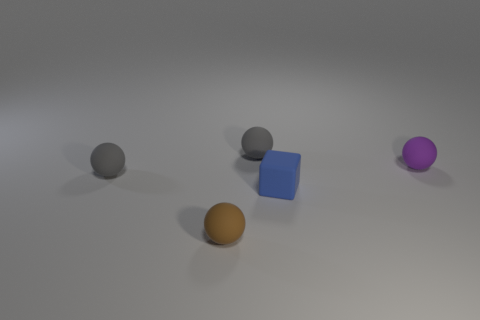Are there any brown things that are in front of the small matte thing that is behind the sphere right of the blue block?
Provide a succinct answer. Yes. How many other things are the same material as the brown thing?
Offer a very short reply. 4. How many tiny gray rubber objects are there?
Provide a short and direct response. 2. What number of objects are yellow cylinders or rubber spheres that are behind the brown thing?
Your answer should be compact. 3. Is there any other thing that has the same shape as the blue matte object?
Your answer should be compact. No. What number of matte things are either brown objects or balls?
Your answer should be very brief. 4. There is a gray rubber ball that is behind the purple rubber thing; what is its size?
Offer a terse response. Small. Is the shape of the small brown object the same as the blue object?
Ensure brevity in your answer.  No. What number of tiny objects are green rubber blocks or gray rubber balls?
Provide a short and direct response. 2. Are there any tiny blue things on the right side of the purple rubber ball?
Keep it short and to the point. No. 